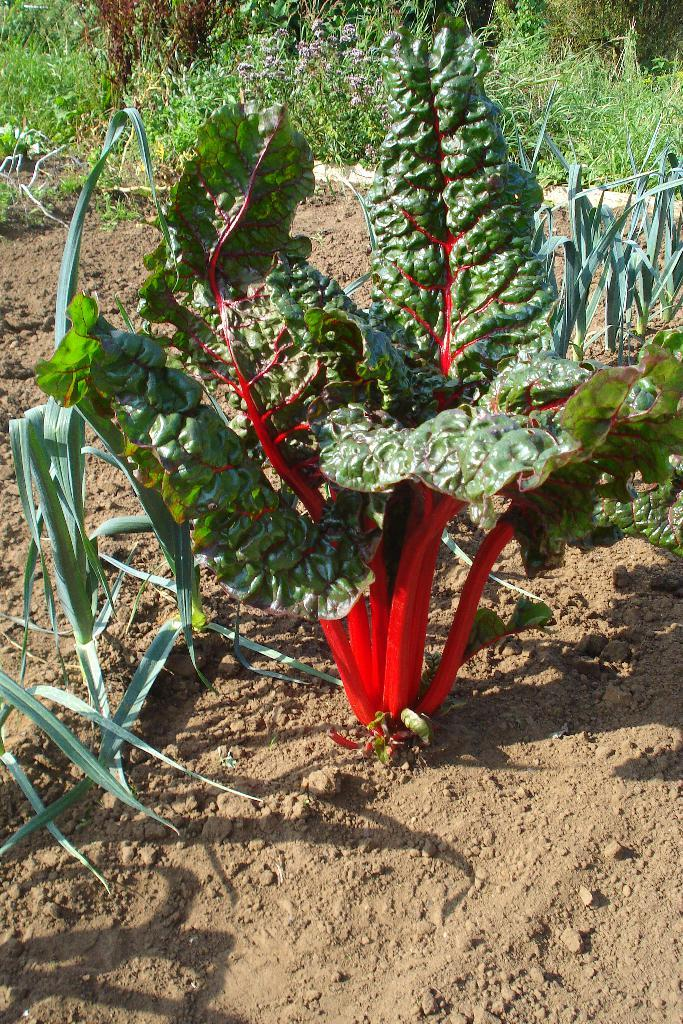What type of vegetation can be seen in the image? There are plants in the image. What type of ground cover is present in the image? There is grass in the image. What color is the mitten that is being worn by the cabbage in the image? There is no cabbage or mitten present in the image; it only features plants and grass. 